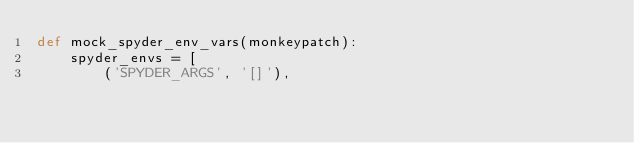<code> <loc_0><loc_0><loc_500><loc_500><_Python_>def mock_spyder_env_vars(monkeypatch):
    spyder_envs = [
        ('SPYDER_ARGS', '[]'),</code> 